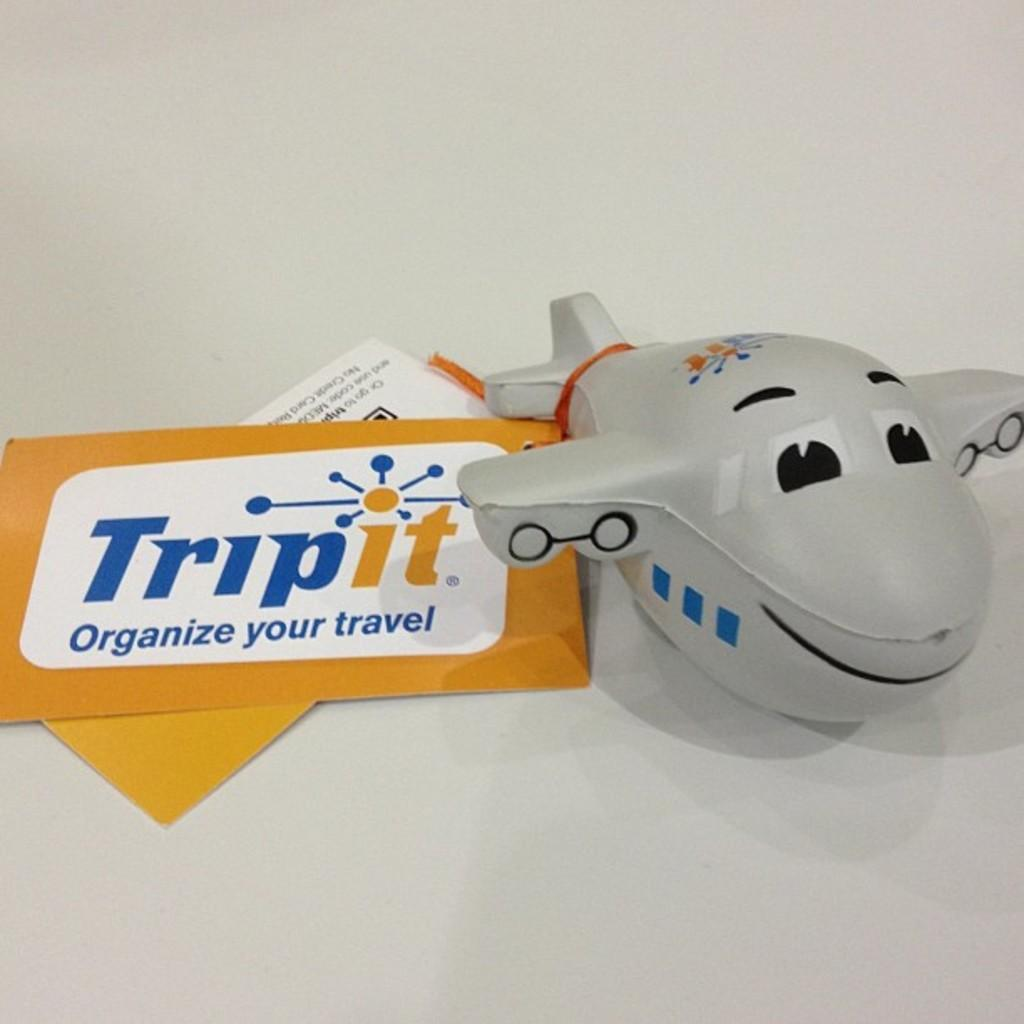<image>
Provide a brief description of the given image. A grey plane toy and a Trip it brand label beside it.beside 